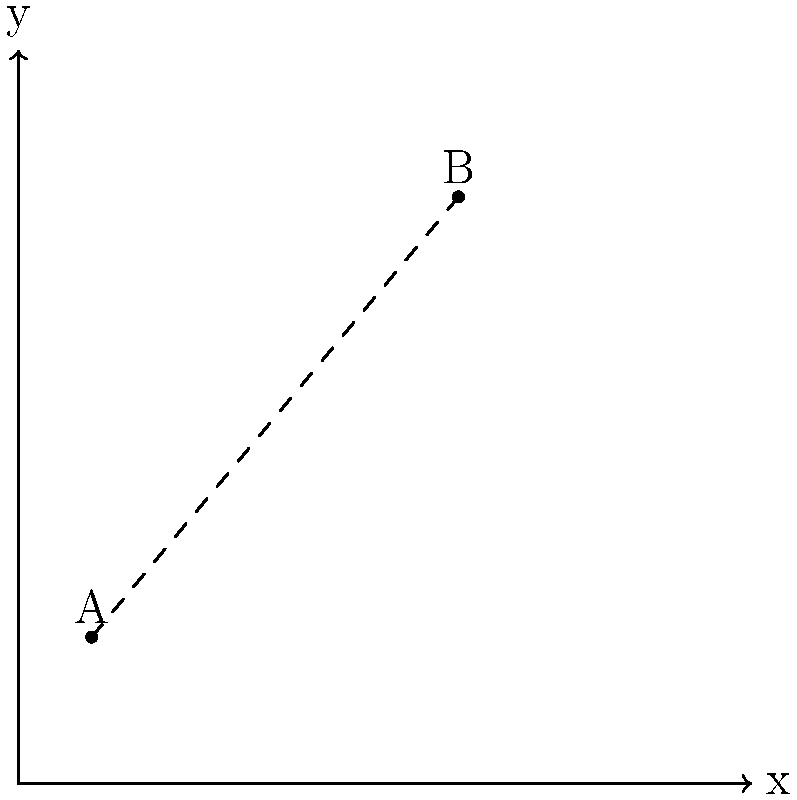A city planner is working on improving community services. Two community centers, A and B, are located on a city map with coordinates A(1,2) and B(6,8). Calculate the straight-line distance between these two centers to determine the area of coverage and potential overlap of services. Use the distance formula and round your answer to two decimal places. To find the distance between two points on a coordinate plane, we use the distance formula:

$$d = \sqrt{(x_2 - x_1)^2 + (y_2 - y_1)^2}$$

Where $(x_1, y_1)$ are the coordinates of the first point and $(x_2, y_2)$ are the coordinates of the second point.

Given:
- Point A: $(1, 2)$
- Point B: $(6, 8)$

Step 1: Identify the coordinates
$x_1 = 1$, $y_1 = 2$
$x_2 = 6$, $y_2 = 8$

Step 2: Plug the values into the distance formula
$$d = \sqrt{(6 - 1)^2 + (8 - 2)^2}$$

Step 3: Simplify inside the parentheses
$$d = \sqrt{(5)^2 + (6)^2}$$

Step 4: Calculate the squares
$$d = \sqrt{25 + 36}$$

Step 5: Add under the square root
$$d = \sqrt{61}$$

Step 6: Calculate the square root and round to two decimal places
$$d \approx 7.81$$

Therefore, the distance between the two community centers is approximately 7.81 units on the city map.
Answer: 7.81 units 